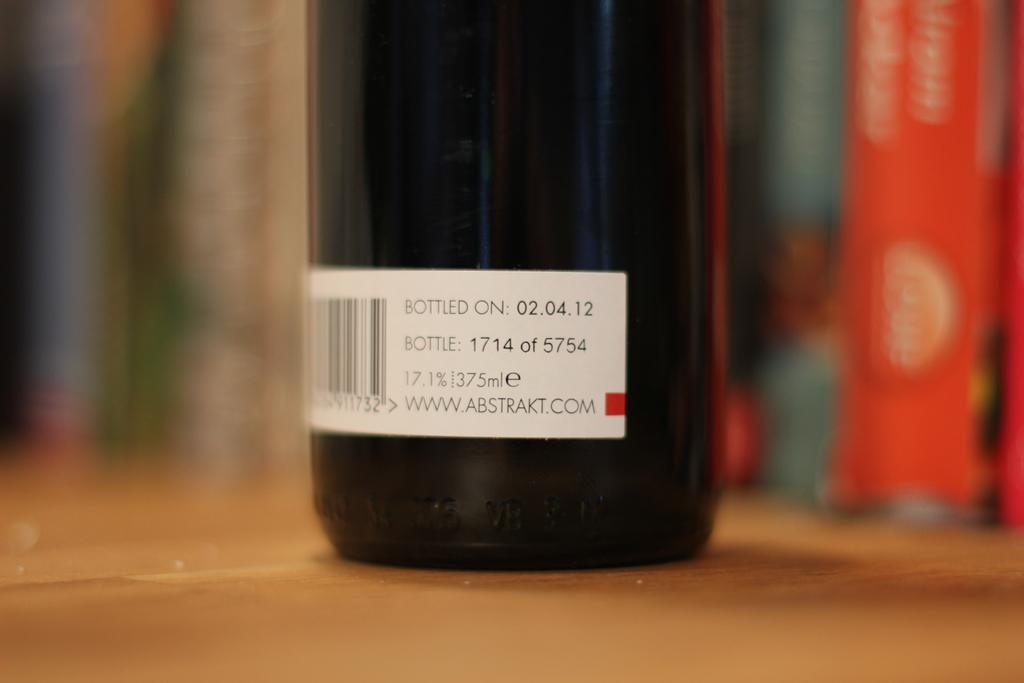What is the date on the bottle?
Provide a succinct answer. 02.04.12. 